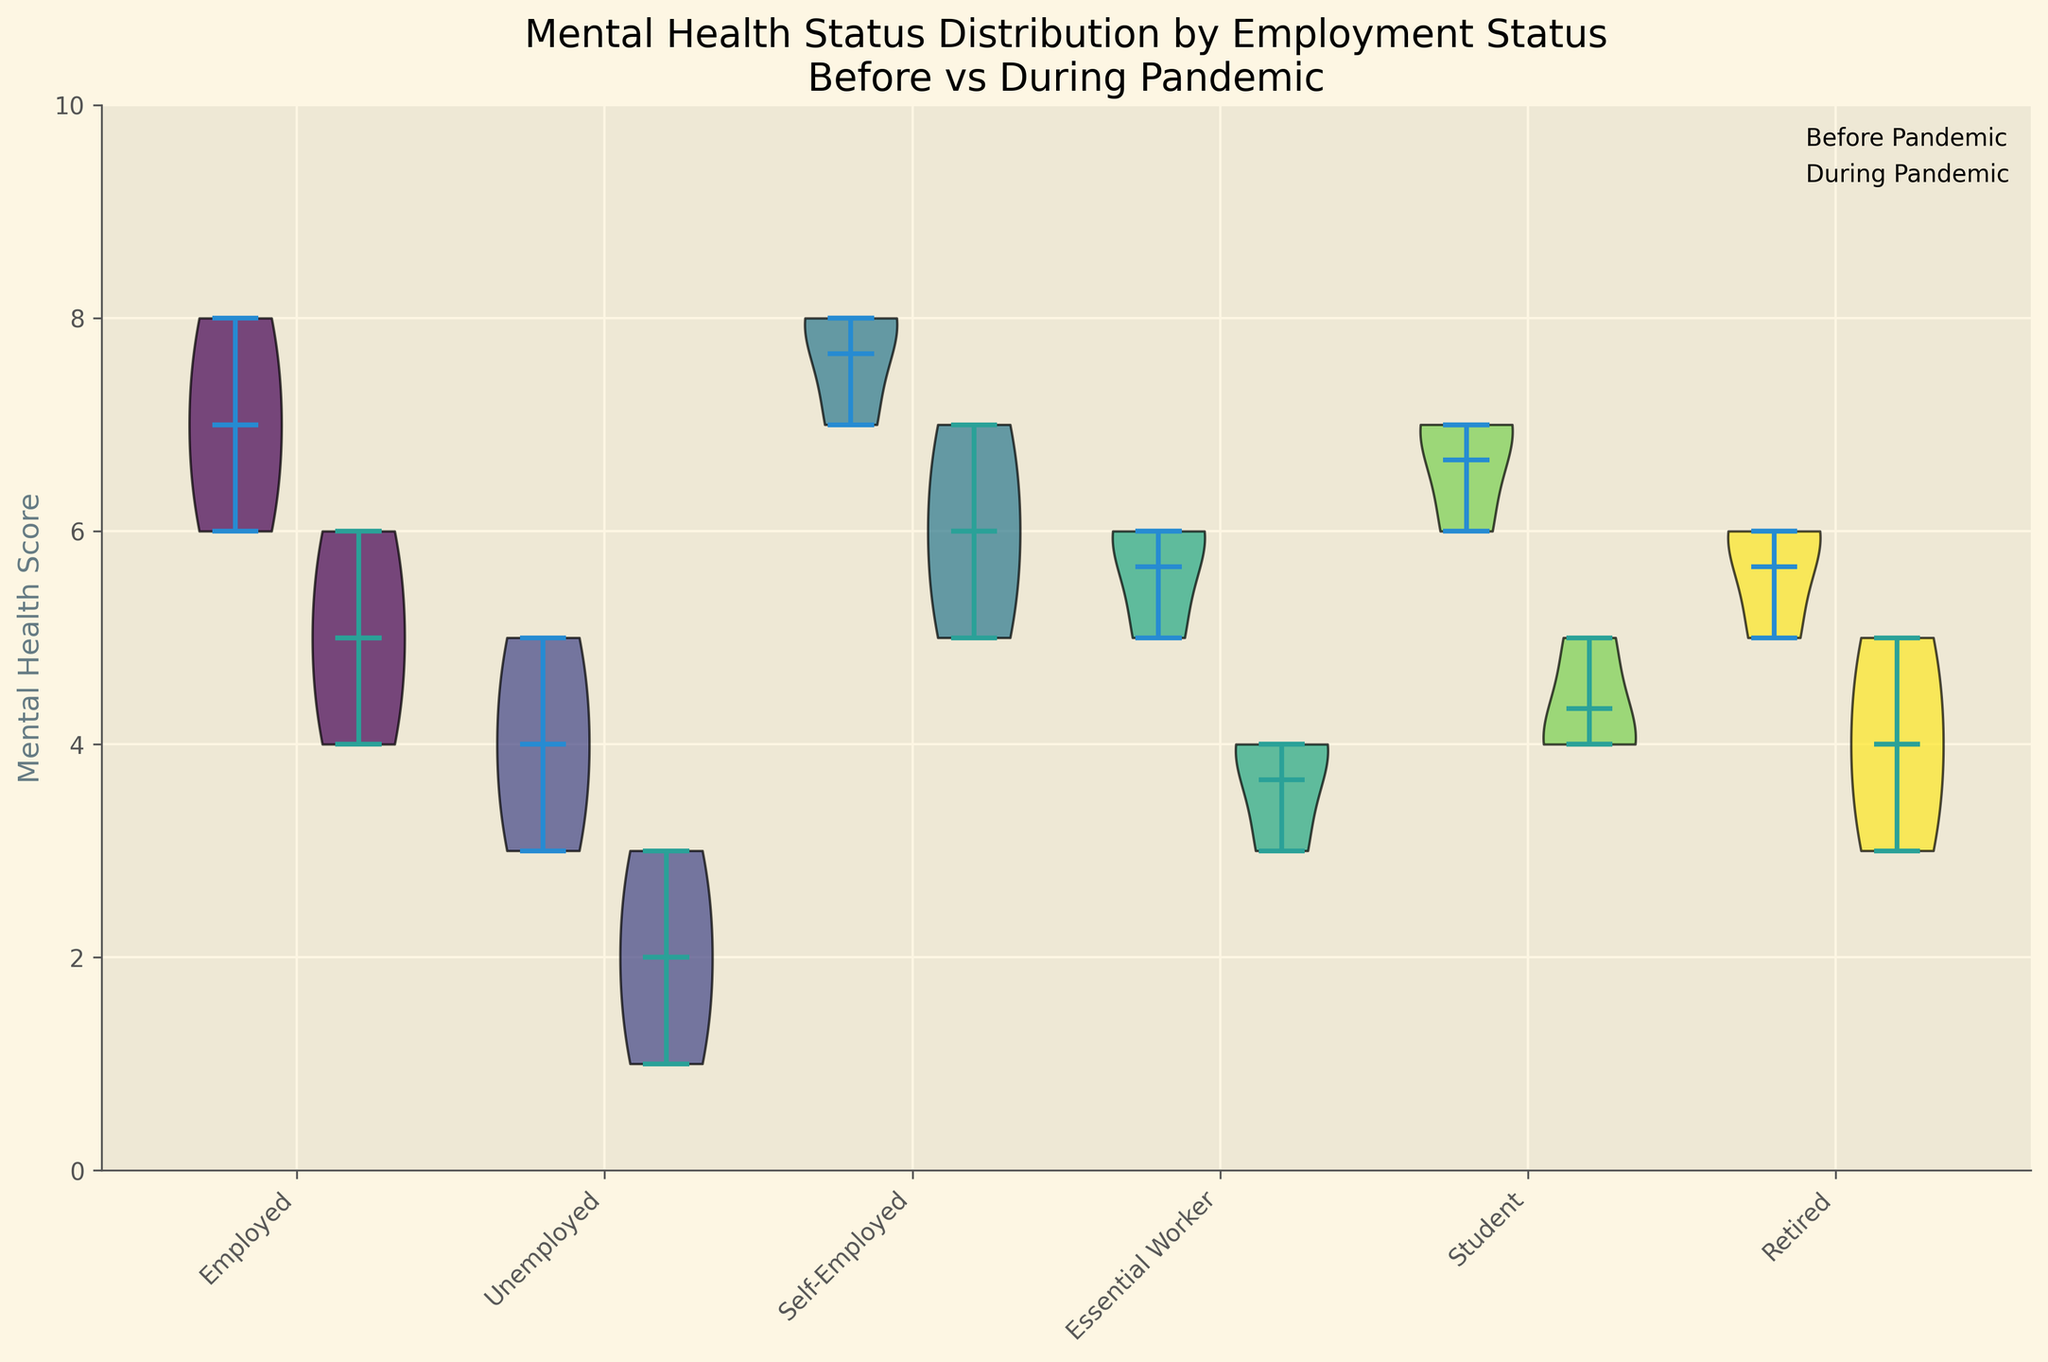What is the title of the figure? The title of the figure is typically displayed at the top and summarizes what the figure is about. By reading it, we can understand the main focus.
Answer: "Mental Health Status Distribution by Employment Status Before vs During Pandemic" What is the y-axis label in the figure? The y-axis label is usually found on the left side of the chart and indicates what is being measured on that axis. In this case, it shows the variable being analyzed.
Answer: "Mental Health Score" How many employment status categories are displayed in the figure? By counting the unique labels or positions on the x-axis, we can determine the number of different employment status categories represented.
Answer: 6 Which employment status had the highest median mental health score before the pandemic? By looking at the center line within the violin plots on the left side (Before Pandemic section), we identify the highest median line.
Answer: "Self-Employed" Did any employment status category show a decrease in the median mental health score during the pandemic? Compare the median lines within each category from Before Pandemic to During Pandemic to observe if there was any decrease.
Answer: Yes, all showed a decrease What was the range of mental health scores for unemployed individuals before the pandemic? The range in a violin plot can be inferred from observing the spread of the outermost points. Look at the "Unemployed" category for the Before Pandemic plot.
Answer: 3 to 5 Which employment status experienced the greatest decrease in median mental health score from before to during the pandemic? Evaluate the difference in the position of the median lines in the Before and During Pandemic sections for each employment status and find the largest gap.
Answer: "Unemployed" How does the mental health score distribution of students change from before to during the pandemic? Compare the shape, spread, and central tendency of the violin plots for the "Student" category before and during the pandemic.
Answer: Decreased and spread narrowed Are there any employment statuses where the distribution of mental health scores overlaps between before and during the pandemic? Look at the violins for each category and see if the distributions intersect or overlap between the Before and During Pandemic sections.
Answer: Yes, there is overlap 